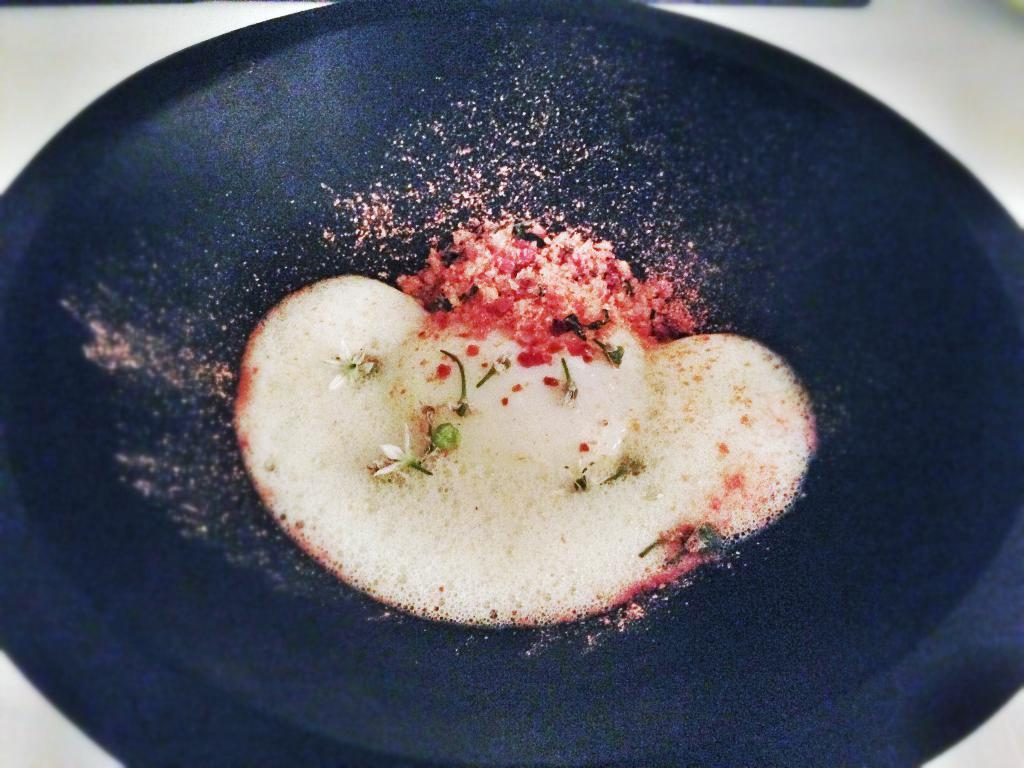What color is the bowl in the image? The bowl in the image is blue. What is inside the bowl? The bowl contains foam and some ingredients. Where is the bowl located? The bowl is placed on a surface. What color is the background of the image? The background of the image is white in color. Can you see a crown on the bowl in the image? No, there is no crown present on the bowl in the image. Are there any instances of a kiss being depicted in the image? No, there are no instances of a kiss being depicted in the image. 